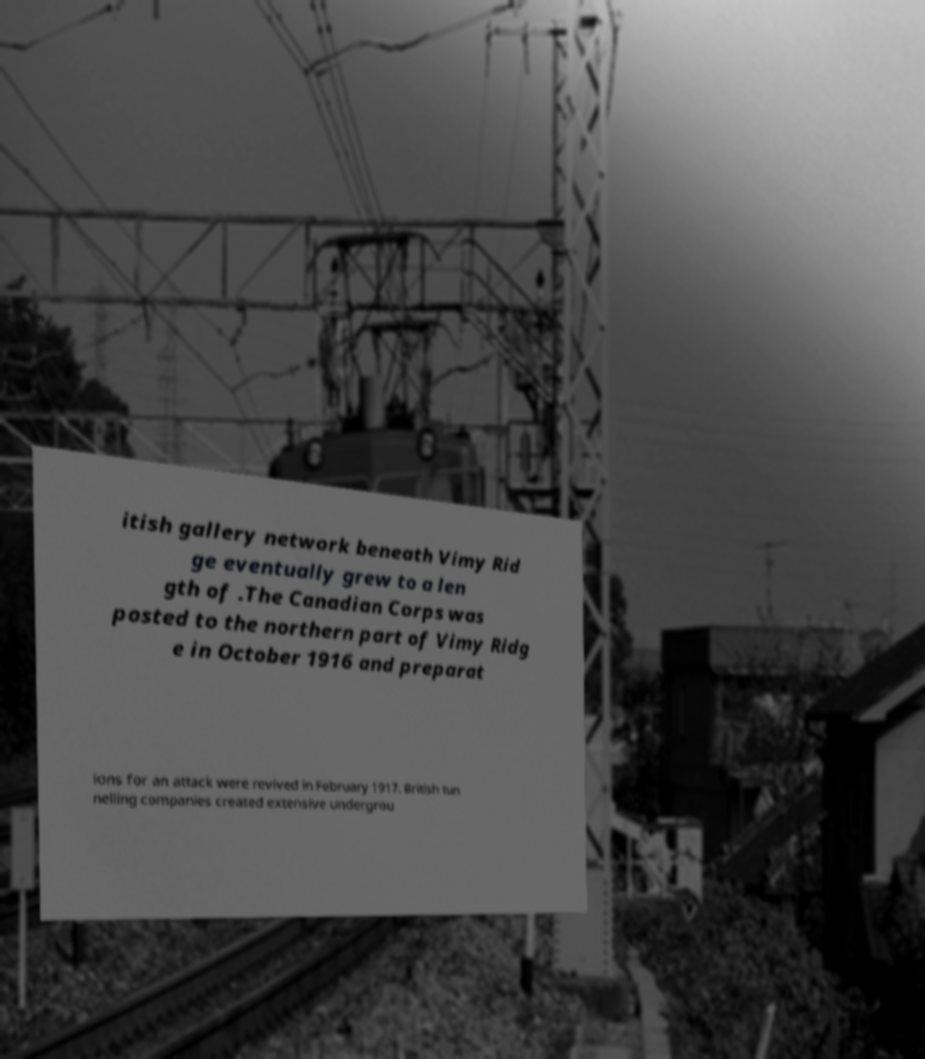Could you assist in decoding the text presented in this image and type it out clearly? itish gallery network beneath Vimy Rid ge eventually grew to a len gth of .The Canadian Corps was posted to the northern part of Vimy Ridg e in October 1916 and preparat ions for an attack were revived in February 1917. British tun nelling companies created extensive undergrou 